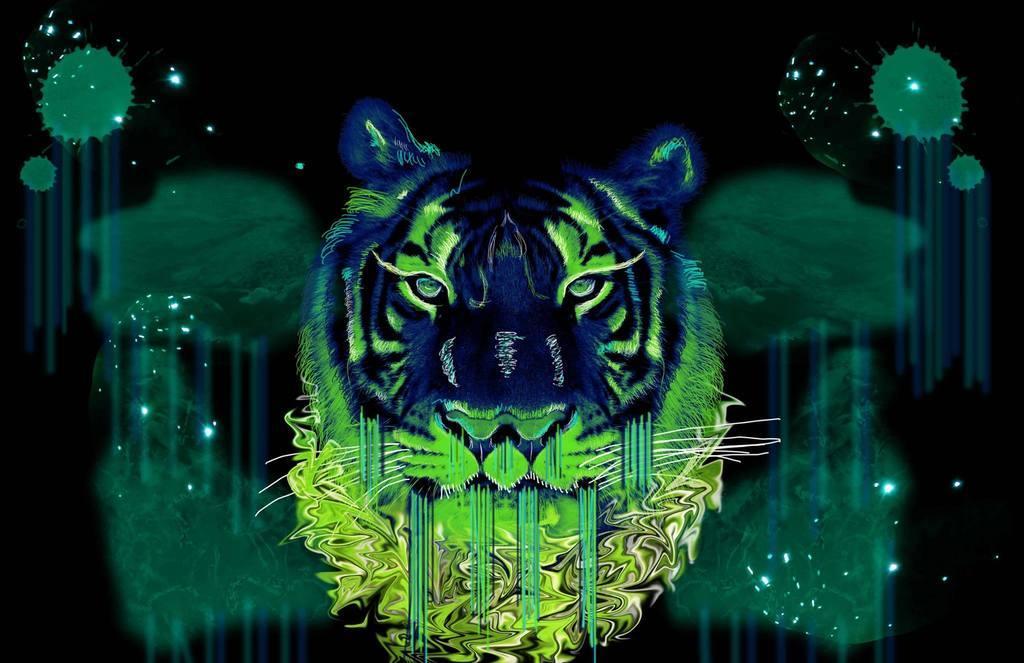Could you give a brief overview of what you see in this image? It is a graphical image. 